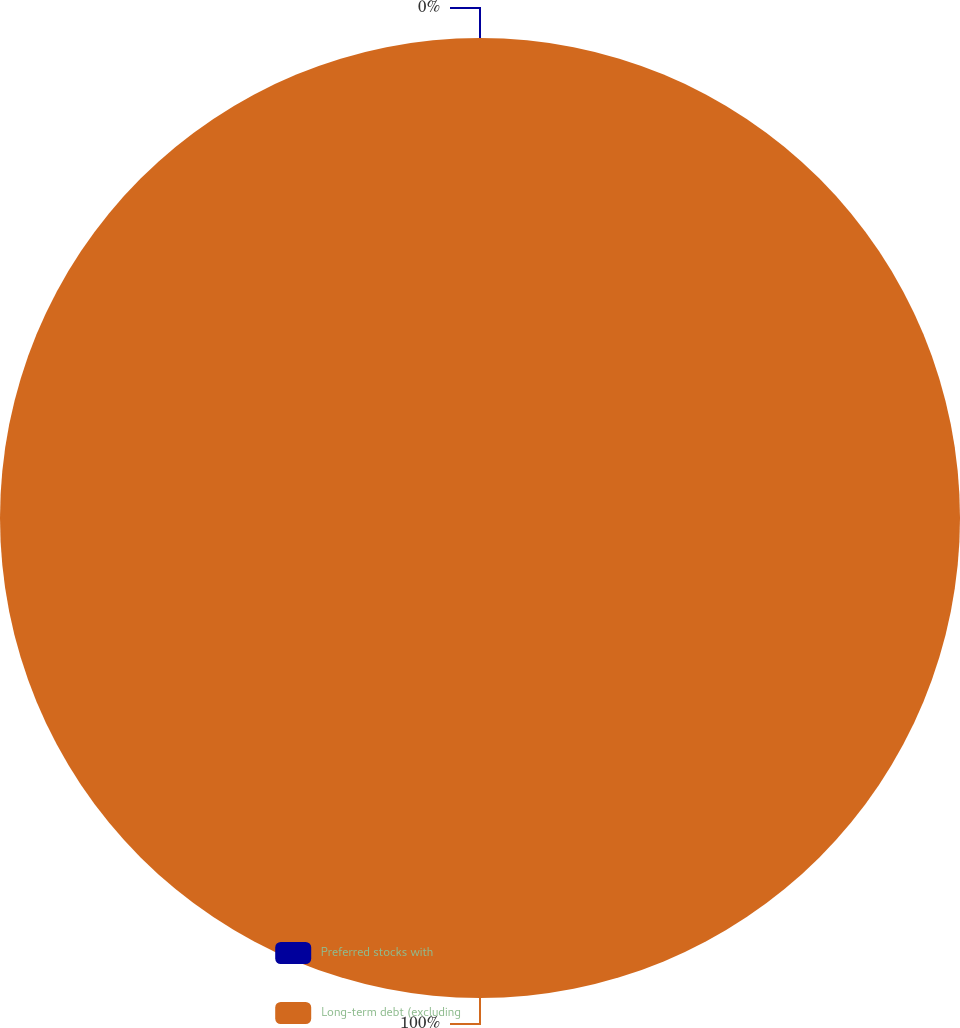<chart> <loc_0><loc_0><loc_500><loc_500><pie_chart><fcel>Preferred stocks with<fcel>Long-term debt (excluding<nl><fcel>0.0%<fcel>100.0%<nl></chart> 